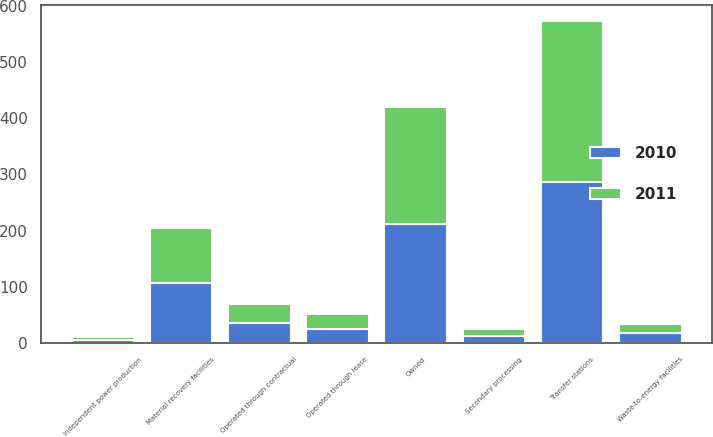Convert chart to OTSL. <chart><loc_0><loc_0><loc_500><loc_500><stacked_bar_chart><ecel><fcel>Owned<fcel>Operated through lease<fcel>Operated through contractual<fcel>Transfer stations<fcel>Material recovery facilities<fcel>Secondary processing<fcel>Waste-to-energy facilities<fcel>Independent power production<nl><fcel>2010<fcel>211<fcel>25<fcel>35<fcel>287<fcel>107<fcel>13<fcel>17<fcel>5<nl><fcel>2011<fcel>210<fcel>26<fcel>35<fcel>286<fcel>98<fcel>12<fcel>17<fcel>5<nl></chart> 